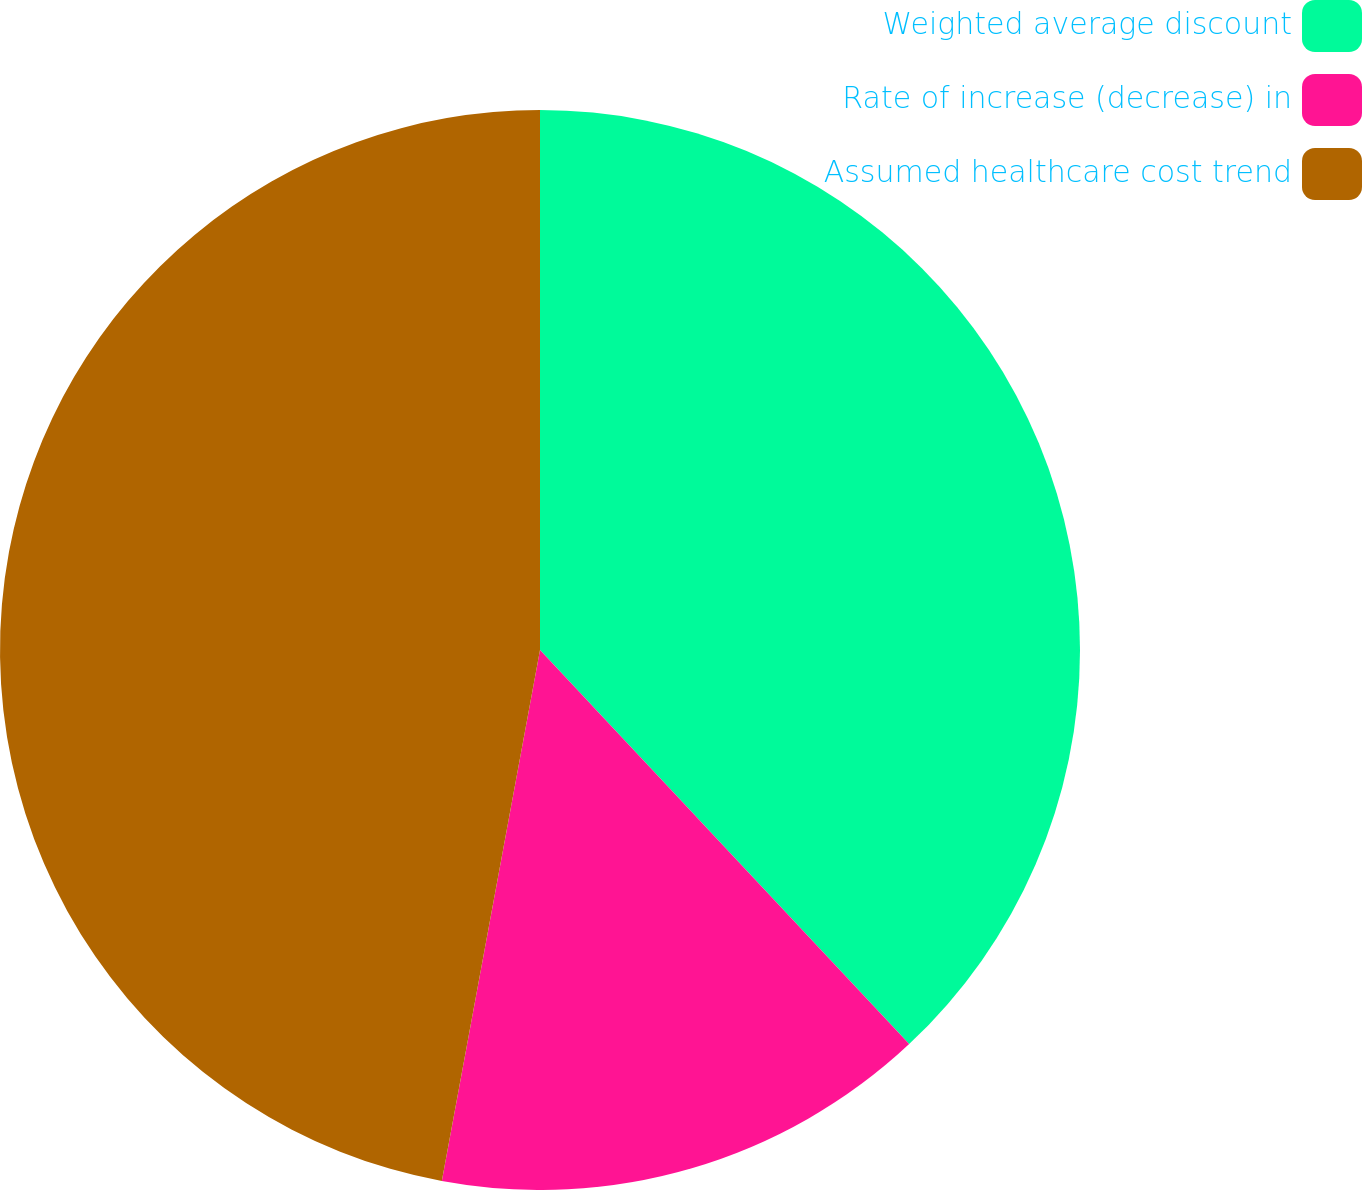<chart> <loc_0><loc_0><loc_500><loc_500><pie_chart><fcel>Weighted average discount<fcel>Rate of increase (decrease) in<fcel>Assumed healthcare cost trend<nl><fcel>38.02%<fcel>14.89%<fcel>47.09%<nl></chart> 